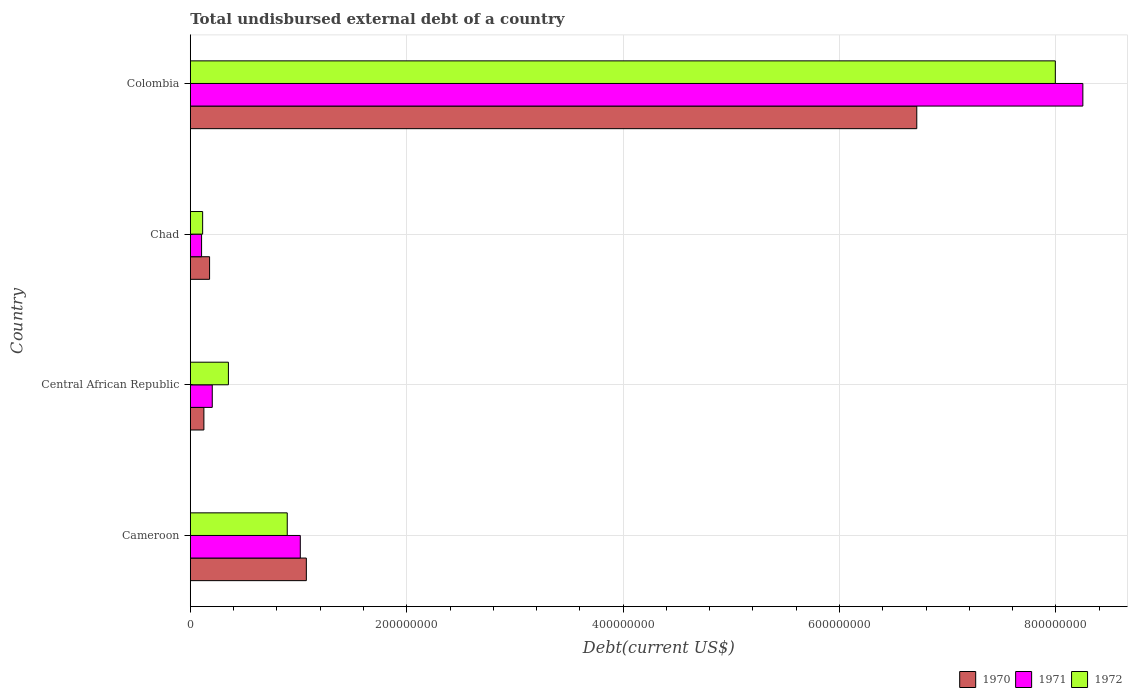What is the label of the 4th group of bars from the top?
Provide a succinct answer. Cameroon. What is the total undisbursed external debt in 1971 in Central African Republic?
Offer a terse response. 2.03e+07. Across all countries, what is the maximum total undisbursed external debt in 1970?
Provide a short and direct response. 6.71e+08. Across all countries, what is the minimum total undisbursed external debt in 1972?
Offer a very short reply. 1.14e+07. In which country was the total undisbursed external debt in 1972 maximum?
Your response must be concise. Colombia. In which country was the total undisbursed external debt in 1971 minimum?
Offer a terse response. Chad. What is the total total undisbursed external debt in 1971 in the graph?
Provide a short and direct response. 9.57e+08. What is the difference between the total undisbursed external debt in 1971 in Cameroon and that in Colombia?
Offer a very short reply. -7.23e+08. What is the difference between the total undisbursed external debt in 1971 in Central African Republic and the total undisbursed external debt in 1970 in Chad?
Give a very brief answer. 2.49e+06. What is the average total undisbursed external debt in 1972 per country?
Provide a succinct answer. 2.34e+08. What is the difference between the total undisbursed external debt in 1970 and total undisbursed external debt in 1972 in Colombia?
Your answer should be compact. -1.28e+08. What is the ratio of the total undisbursed external debt in 1972 in Cameroon to that in Colombia?
Your answer should be compact. 0.11. Is the total undisbursed external debt in 1970 in Central African Republic less than that in Chad?
Your response must be concise. Yes. Is the difference between the total undisbursed external debt in 1970 in Central African Republic and Colombia greater than the difference between the total undisbursed external debt in 1972 in Central African Republic and Colombia?
Your answer should be very brief. Yes. What is the difference between the highest and the second highest total undisbursed external debt in 1970?
Give a very brief answer. 5.64e+08. What is the difference between the highest and the lowest total undisbursed external debt in 1972?
Give a very brief answer. 7.88e+08. How many bars are there?
Your response must be concise. 12. What is the difference between two consecutive major ticks on the X-axis?
Keep it short and to the point. 2.00e+08. Are the values on the major ticks of X-axis written in scientific E-notation?
Your answer should be very brief. No. Does the graph contain grids?
Your response must be concise. Yes. Where does the legend appear in the graph?
Your answer should be compact. Bottom right. How many legend labels are there?
Keep it short and to the point. 3. How are the legend labels stacked?
Ensure brevity in your answer.  Horizontal. What is the title of the graph?
Keep it short and to the point. Total undisbursed external debt of a country. What is the label or title of the X-axis?
Your response must be concise. Debt(current US$). What is the Debt(current US$) of 1970 in Cameroon?
Give a very brief answer. 1.07e+08. What is the Debt(current US$) in 1971 in Cameroon?
Your answer should be very brief. 1.02e+08. What is the Debt(current US$) of 1972 in Cameroon?
Offer a very short reply. 8.96e+07. What is the Debt(current US$) in 1970 in Central African Republic?
Make the answer very short. 1.26e+07. What is the Debt(current US$) in 1971 in Central African Republic?
Ensure brevity in your answer.  2.03e+07. What is the Debt(current US$) of 1972 in Central African Republic?
Your response must be concise. 3.52e+07. What is the Debt(current US$) in 1970 in Chad?
Offer a very short reply. 1.78e+07. What is the Debt(current US$) in 1971 in Chad?
Offer a very short reply. 1.04e+07. What is the Debt(current US$) in 1972 in Chad?
Ensure brevity in your answer.  1.14e+07. What is the Debt(current US$) of 1970 in Colombia?
Your response must be concise. 6.71e+08. What is the Debt(current US$) of 1971 in Colombia?
Offer a terse response. 8.25e+08. What is the Debt(current US$) in 1972 in Colombia?
Your response must be concise. 7.99e+08. Across all countries, what is the maximum Debt(current US$) of 1970?
Ensure brevity in your answer.  6.71e+08. Across all countries, what is the maximum Debt(current US$) of 1971?
Keep it short and to the point. 8.25e+08. Across all countries, what is the maximum Debt(current US$) of 1972?
Your answer should be compact. 7.99e+08. Across all countries, what is the minimum Debt(current US$) in 1970?
Make the answer very short. 1.26e+07. Across all countries, what is the minimum Debt(current US$) of 1971?
Provide a short and direct response. 1.04e+07. Across all countries, what is the minimum Debt(current US$) in 1972?
Ensure brevity in your answer.  1.14e+07. What is the total Debt(current US$) of 1970 in the graph?
Give a very brief answer. 8.09e+08. What is the total Debt(current US$) in 1971 in the graph?
Your answer should be very brief. 9.57e+08. What is the total Debt(current US$) of 1972 in the graph?
Keep it short and to the point. 9.36e+08. What is the difference between the Debt(current US$) of 1970 in Cameroon and that in Central African Republic?
Ensure brevity in your answer.  9.47e+07. What is the difference between the Debt(current US$) of 1971 in Cameroon and that in Central African Republic?
Your answer should be compact. 8.14e+07. What is the difference between the Debt(current US$) in 1972 in Cameroon and that in Central African Republic?
Your response must be concise. 5.44e+07. What is the difference between the Debt(current US$) of 1970 in Cameroon and that in Chad?
Provide a succinct answer. 8.94e+07. What is the difference between the Debt(current US$) in 1971 in Cameroon and that in Chad?
Your answer should be compact. 9.12e+07. What is the difference between the Debt(current US$) of 1972 in Cameroon and that in Chad?
Offer a very short reply. 7.82e+07. What is the difference between the Debt(current US$) in 1970 in Cameroon and that in Colombia?
Offer a very short reply. -5.64e+08. What is the difference between the Debt(current US$) in 1971 in Cameroon and that in Colombia?
Your answer should be compact. -7.23e+08. What is the difference between the Debt(current US$) of 1972 in Cameroon and that in Colombia?
Offer a very short reply. -7.10e+08. What is the difference between the Debt(current US$) in 1970 in Central African Republic and that in Chad?
Your answer should be compact. -5.25e+06. What is the difference between the Debt(current US$) of 1971 in Central African Republic and that in Chad?
Make the answer very short. 9.88e+06. What is the difference between the Debt(current US$) of 1972 in Central African Republic and that in Chad?
Your response must be concise. 2.38e+07. What is the difference between the Debt(current US$) of 1970 in Central African Republic and that in Colombia?
Offer a very short reply. -6.59e+08. What is the difference between the Debt(current US$) in 1971 in Central African Republic and that in Colombia?
Provide a succinct answer. -8.05e+08. What is the difference between the Debt(current US$) of 1972 in Central African Republic and that in Colombia?
Your answer should be compact. -7.64e+08. What is the difference between the Debt(current US$) of 1970 in Chad and that in Colombia?
Offer a very short reply. -6.54e+08. What is the difference between the Debt(current US$) in 1971 in Chad and that in Colombia?
Your answer should be compact. -8.14e+08. What is the difference between the Debt(current US$) of 1972 in Chad and that in Colombia?
Ensure brevity in your answer.  -7.88e+08. What is the difference between the Debt(current US$) of 1970 in Cameroon and the Debt(current US$) of 1971 in Central African Republic?
Offer a very short reply. 8.69e+07. What is the difference between the Debt(current US$) in 1970 in Cameroon and the Debt(current US$) in 1972 in Central African Republic?
Your answer should be compact. 7.20e+07. What is the difference between the Debt(current US$) in 1971 in Cameroon and the Debt(current US$) in 1972 in Central African Republic?
Keep it short and to the point. 6.64e+07. What is the difference between the Debt(current US$) in 1970 in Cameroon and the Debt(current US$) in 1971 in Chad?
Ensure brevity in your answer.  9.68e+07. What is the difference between the Debt(current US$) in 1970 in Cameroon and the Debt(current US$) in 1972 in Chad?
Offer a very short reply. 9.58e+07. What is the difference between the Debt(current US$) of 1971 in Cameroon and the Debt(current US$) of 1972 in Chad?
Keep it short and to the point. 9.03e+07. What is the difference between the Debt(current US$) of 1970 in Cameroon and the Debt(current US$) of 1971 in Colombia?
Offer a very short reply. -7.18e+08. What is the difference between the Debt(current US$) of 1970 in Cameroon and the Debt(current US$) of 1972 in Colombia?
Your answer should be compact. -6.92e+08. What is the difference between the Debt(current US$) in 1971 in Cameroon and the Debt(current US$) in 1972 in Colombia?
Your answer should be very brief. -6.98e+08. What is the difference between the Debt(current US$) of 1970 in Central African Republic and the Debt(current US$) of 1971 in Chad?
Offer a very short reply. 2.13e+06. What is the difference between the Debt(current US$) in 1970 in Central African Republic and the Debt(current US$) in 1972 in Chad?
Provide a succinct answer. 1.15e+06. What is the difference between the Debt(current US$) in 1971 in Central African Republic and the Debt(current US$) in 1972 in Chad?
Provide a short and direct response. 8.90e+06. What is the difference between the Debt(current US$) in 1970 in Central African Republic and the Debt(current US$) in 1971 in Colombia?
Ensure brevity in your answer.  -8.12e+08. What is the difference between the Debt(current US$) of 1970 in Central African Republic and the Debt(current US$) of 1972 in Colombia?
Keep it short and to the point. -7.87e+08. What is the difference between the Debt(current US$) in 1971 in Central African Republic and the Debt(current US$) in 1972 in Colombia?
Offer a very short reply. -7.79e+08. What is the difference between the Debt(current US$) of 1970 in Chad and the Debt(current US$) of 1971 in Colombia?
Your response must be concise. -8.07e+08. What is the difference between the Debt(current US$) of 1970 in Chad and the Debt(current US$) of 1972 in Colombia?
Ensure brevity in your answer.  -7.82e+08. What is the difference between the Debt(current US$) of 1971 in Chad and the Debt(current US$) of 1972 in Colombia?
Your response must be concise. -7.89e+08. What is the average Debt(current US$) in 1970 per country?
Make the answer very short. 2.02e+08. What is the average Debt(current US$) in 1971 per country?
Give a very brief answer. 2.39e+08. What is the average Debt(current US$) of 1972 per country?
Give a very brief answer. 2.34e+08. What is the difference between the Debt(current US$) in 1970 and Debt(current US$) in 1971 in Cameroon?
Offer a very short reply. 5.58e+06. What is the difference between the Debt(current US$) in 1970 and Debt(current US$) in 1972 in Cameroon?
Offer a terse response. 1.77e+07. What is the difference between the Debt(current US$) of 1971 and Debt(current US$) of 1972 in Cameroon?
Your answer should be very brief. 1.21e+07. What is the difference between the Debt(current US$) in 1970 and Debt(current US$) in 1971 in Central African Republic?
Make the answer very short. -7.74e+06. What is the difference between the Debt(current US$) in 1970 and Debt(current US$) in 1972 in Central African Republic?
Provide a short and direct response. -2.27e+07. What is the difference between the Debt(current US$) of 1971 and Debt(current US$) of 1972 in Central African Republic?
Offer a terse response. -1.49e+07. What is the difference between the Debt(current US$) in 1970 and Debt(current US$) in 1971 in Chad?
Provide a short and direct response. 7.38e+06. What is the difference between the Debt(current US$) in 1970 and Debt(current US$) in 1972 in Chad?
Your answer should be compact. 6.41e+06. What is the difference between the Debt(current US$) of 1971 and Debt(current US$) of 1972 in Chad?
Your response must be concise. -9.77e+05. What is the difference between the Debt(current US$) of 1970 and Debt(current US$) of 1971 in Colombia?
Offer a very short reply. -1.53e+08. What is the difference between the Debt(current US$) of 1970 and Debt(current US$) of 1972 in Colombia?
Your answer should be compact. -1.28e+08. What is the difference between the Debt(current US$) in 1971 and Debt(current US$) in 1972 in Colombia?
Give a very brief answer. 2.54e+07. What is the ratio of the Debt(current US$) in 1970 in Cameroon to that in Central African Republic?
Your answer should be compact. 8.54. What is the ratio of the Debt(current US$) in 1971 in Cameroon to that in Central African Republic?
Keep it short and to the point. 5.01. What is the ratio of the Debt(current US$) in 1972 in Cameroon to that in Central African Republic?
Offer a very short reply. 2.54. What is the ratio of the Debt(current US$) in 1970 in Cameroon to that in Chad?
Give a very brief answer. 6.02. What is the ratio of the Debt(current US$) of 1971 in Cameroon to that in Chad?
Ensure brevity in your answer.  9.75. What is the ratio of the Debt(current US$) of 1972 in Cameroon to that in Chad?
Your answer should be compact. 7.85. What is the ratio of the Debt(current US$) in 1970 in Cameroon to that in Colombia?
Provide a short and direct response. 0.16. What is the ratio of the Debt(current US$) of 1971 in Cameroon to that in Colombia?
Make the answer very short. 0.12. What is the ratio of the Debt(current US$) of 1972 in Cameroon to that in Colombia?
Make the answer very short. 0.11. What is the ratio of the Debt(current US$) of 1970 in Central African Republic to that in Chad?
Give a very brief answer. 0.71. What is the ratio of the Debt(current US$) in 1971 in Central African Republic to that in Chad?
Offer a very short reply. 1.95. What is the ratio of the Debt(current US$) of 1972 in Central African Republic to that in Chad?
Offer a very short reply. 3.09. What is the ratio of the Debt(current US$) in 1970 in Central African Republic to that in Colombia?
Offer a very short reply. 0.02. What is the ratio of the Debt(current US$) in 1971 in Central African Republic to that in Colombia?
Make the answer very short. 0.02. What is the ratio of the Debt(current US$) in 1972 in Central African Republic to that in Colombia?
Ensure brevity in your answer.  0.04. What is the ratio of the Debt(current US$) of 1970 in Chad to that in Colombia?
Give a very brief answer. 0.03. What is the ratio of the Debt(current US$) in 1971 in Chad to that in Colombia?
Your answer should be compact. 0.01. What is the ratio of the Debt(current US$) of 1972 in Chad to that in Colombia?
Ensure brevity in your answer.  0.01. What is the difference between the highest and the second highest Debt(current US$) in 1970?
Provide a succinct answer. 5.64e+08. What is the difference between the highest and the second highest Debt(current US$) in 1971?
Your response must be concise. 7.23e+08. What is the difference between the highest and the second highest Debt(current US$) of 1972?
Give a very brief answer. 7.10e+08. What is the difference between the highest and the lowest Debt(current US$) in 1970?
Your answer should be very brief. 6.59e+08. What is the difference between the highest and the lowest Debt(current US$) in 1971?
Give a very brief answer. 8.14e+08. What is the difference between the highest and the lowest Debt(current US$) in 1972?
Make the answer very short. 7.88e+08. 